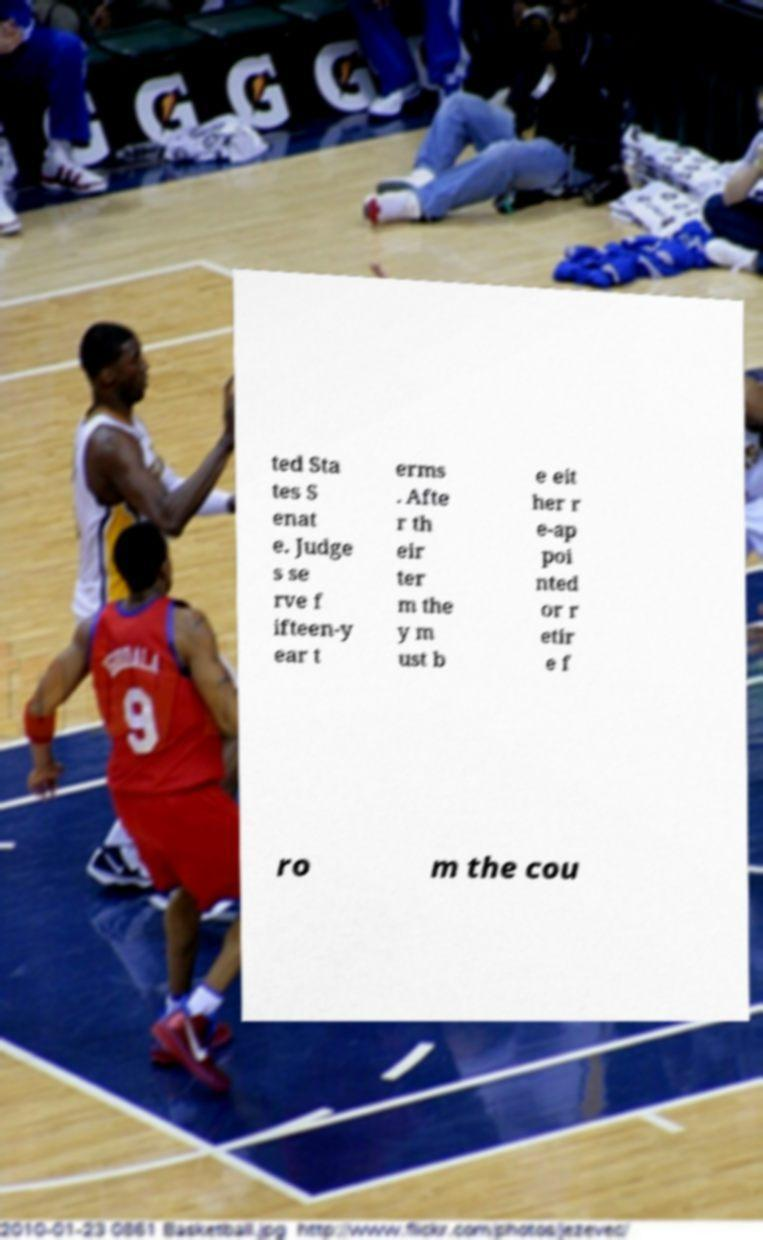Please identify and transcribe the text found in this image. ted Sta tes S enat e. Judge s se rve f ifteen-y ear t erms . Afte r th eir ter m the y m ust b e eit her r e-ap poi nted or r etir e f ro m the cou 